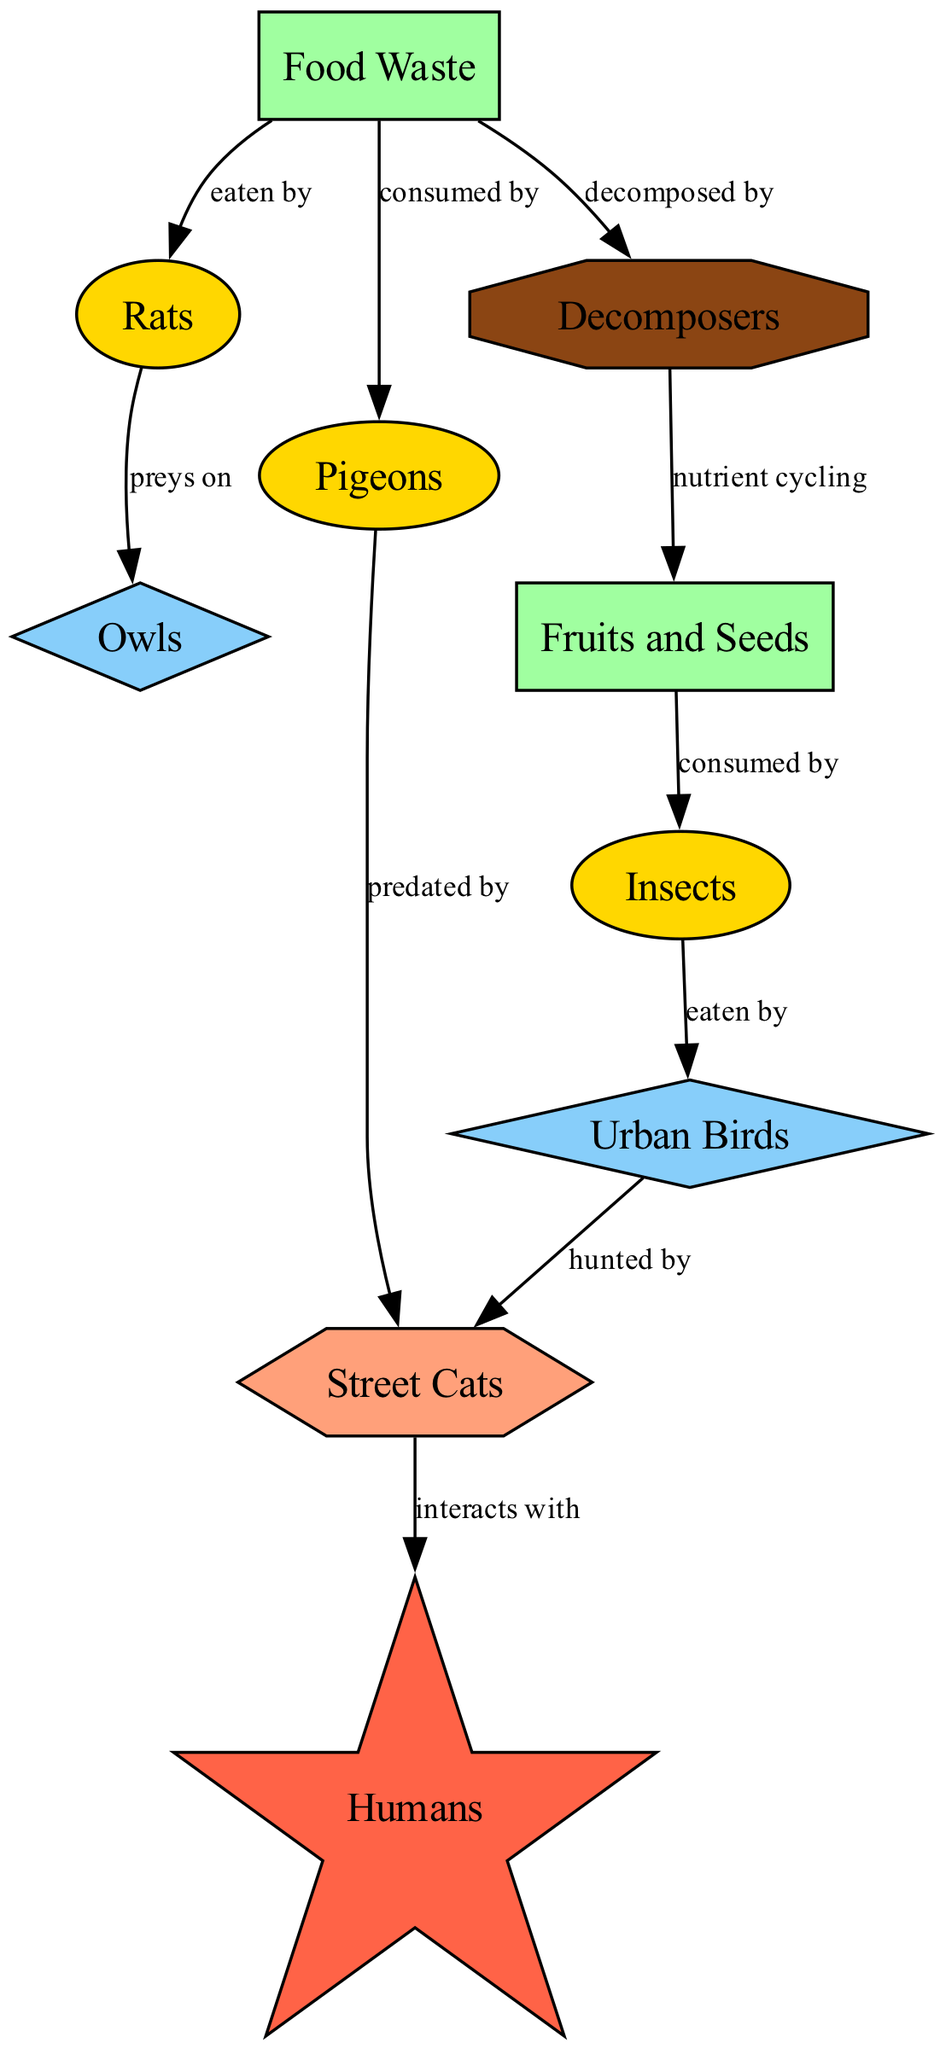What is the primary producer in this food chain? According to the diagram, the primary producers are labeled as "Fruits and Seeds" and "Food Waste." These nodes are the sources of energy in the food chain. The first node listed is "Fruits and Seeds," which serves as the primary producer in this context.
Answer: Fruits and Seeds How many primary consumers are present in the diagram? The diagram lists three nodes under the "primary_consumer" type: "Insects," "Rats," and "Pigeons." Counting these nodes gives a total of three primary consumers in the food chain.
Answer: 3 Who is the apex predator in the food chain? The apex predator is indicated in the diagram by the label "Humans," which is the highest consumer without any natural predators in this context.
Answer: Humans What is the relationship between "Urban Birds" and "Street Cats"? The diagram shows that "Urban Birds" are hunted by "Street Cats." This indicates a predatory relationship where street cats prey on urban birds for food.
Answer: hunted by Which node is directly related to the "Decomposers"? The "Decomposers" node in the diagram is directly connected to "Food Waste." This relationship highlights the role of decomposers in breaking down food waste and recycling nutrients in the food chain.
Answer: Food Waste What type of nodes are "Owls" and "Urban Birds"? Both "Owls" and "Urban Birds" are categorized as "secondary_consumer," which designates their role in the food chain as consumers that eat primary consumers like insects or pigeons.
Answer: secondary_consumer How many edges are present in the diagram? By counting the connections (edges) between nodes in the diagram, it is found that there are a total of ten edges connecting various nodes that depict relationships in the food chain.
Answer: 10 What happens to the "Food Waste" according to the diagram? The diagram indicates that "Food Waste" is eaten by "Rats" and also decomposed by "Decomposers." This shows the two primary interactions of food waste in urban wildlife.
Answer: eaten by, decomposed by What type of node is "Street Cats"? "Street Cats" are categorized as a "tertiary_consumer" in the diagram, indicating they are top predators that mainly prey on secondary consumers like urban birds.
Answer: tertiary_consumer 